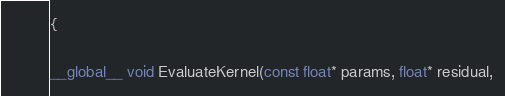Convert code to text. <code><loc_0><loc_0><loc_500><loc_500><_Cuda_>{

__global__ void EvaluateKernel(const float* params, float* residual,</code> 